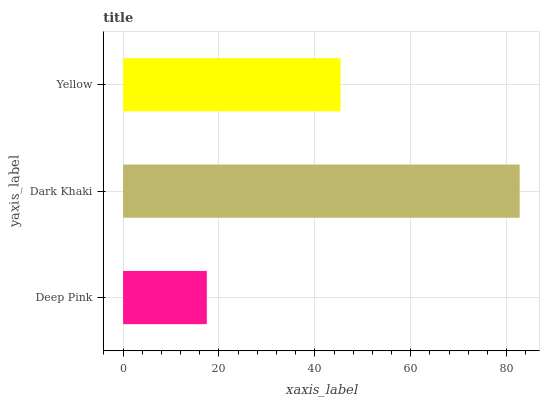Is Deep Pink the minimum?
Answer yes or no. Yes. Is Dark Khaki the maximum?
Answer yes or no. Yes. Is Yellow the minimum?
Answer yes or no. No. Is Yellow the maximum?
Answer yes or no. No. Is Dark Khaki greater than Yellow?
Answer yes or no. Yes. Is Yellow less than Dark Khaki?
Answer yes or no. Yes. Is Yellow greater than Dark Khaki?
Answer yes or no. No. Is Dark Khaki less than Yellow?
Answer yes or no. No. Is Yellow the high median?
Answer yes or no. Yes. Is Yellow the low median?
Answer yes or no. Yes. Is Dark Khaki the high median?
Answer yes or no. No. Is Dark Khaki the low median?
Answer yes or no. No. 